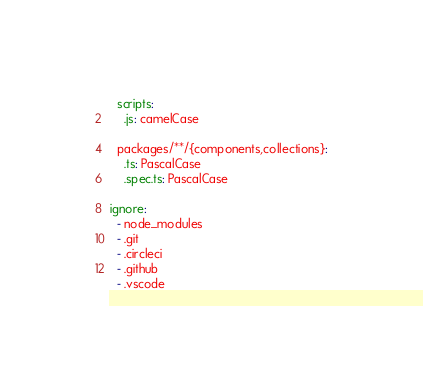<code> <loc_0><loc_0><loc_500><loc_500><_YAML_>
  scripts:
    .js: camelCase

  packages/**/{components,collections}:
    .ts: PascalCase
    .spec.ts: PascalCase

ignore:
  - node_modules
  - .git
  - .circleci
  - .github
  - .vscode
</code> 